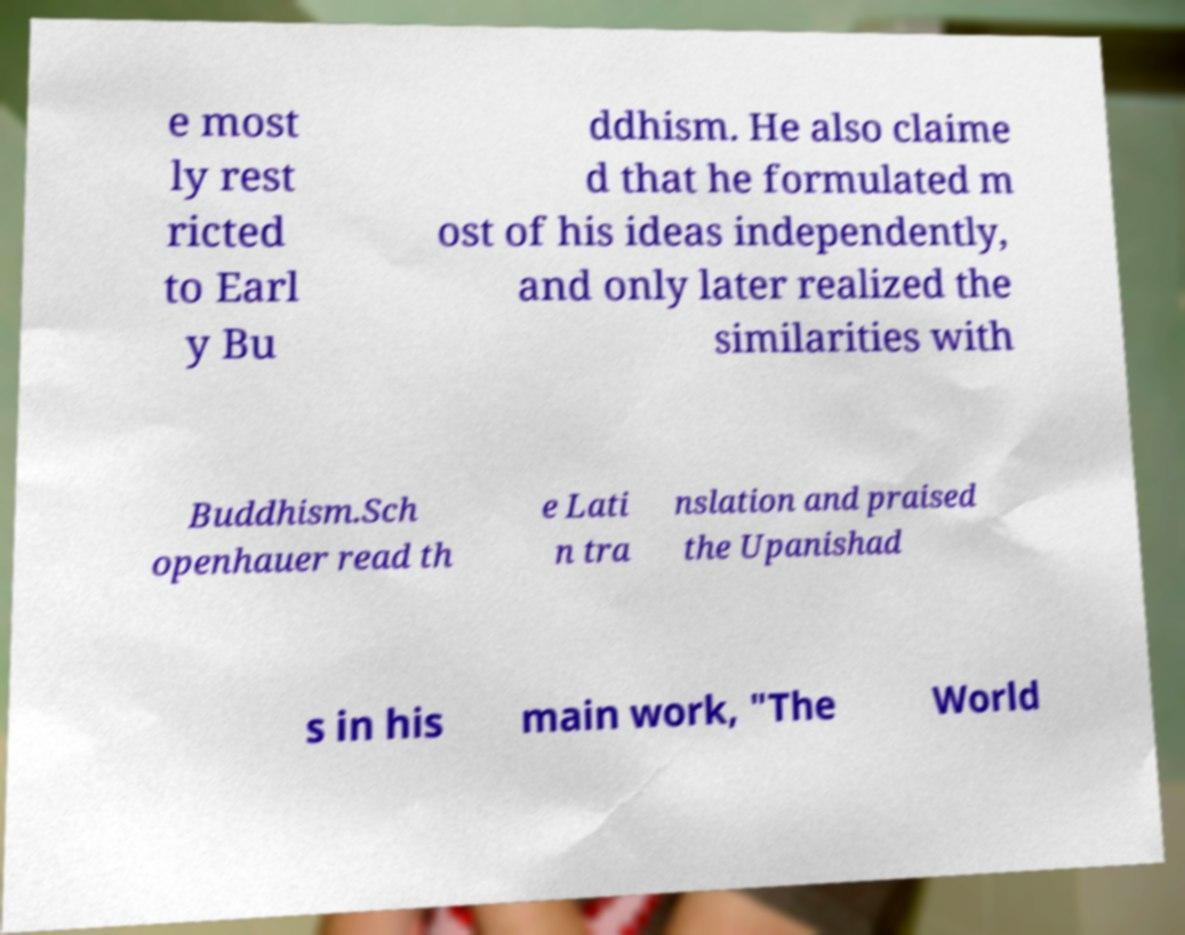Please identify and transcribe the text found in this image. e most ly rest ricted to Earl y Bu ddhism. He also claime d that he formulated m ost of his ideas independently, and only later realized the similarities with Buddhism.Sch openhauer read th e Lati n tra nslation and praised the Upanishad s in his main work, "The World 